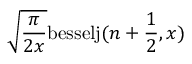Convert formula to latex. <formula><loc_0><loc_0><loc_500><loc_500>\sqrt { \frac { \pi } { 2 x } } b e s s e l j ( n + \frac { 1 } { 2 } , x )</formula> 